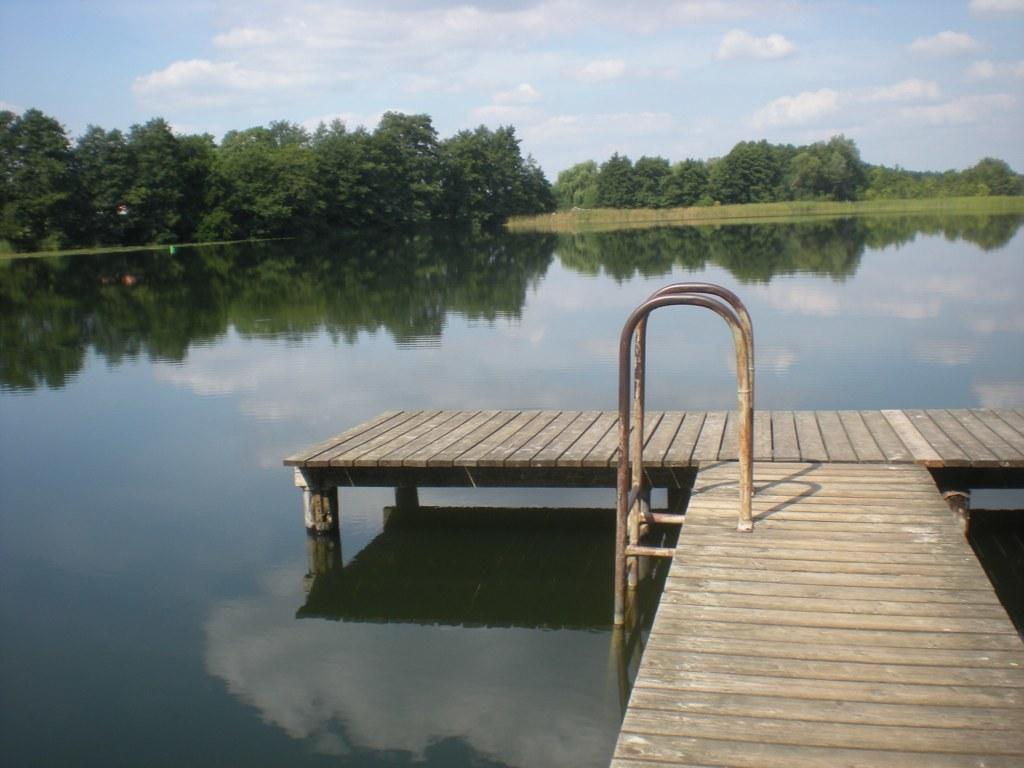What type of structure is present in the image? There is a wooden pier in the image. What can be seen near the wooden pier? There is a step pool ladder visible in the image. What is the primary natural element in the image? Water is visible in the image. What type of vegetation is present in the image? There are trees in the image. What is visible in the background of the image? The sky is visible in the background of the image. What language is spoken by the twig in the image? There is no twig present in the image, and therefore no language can be attributed to it. 